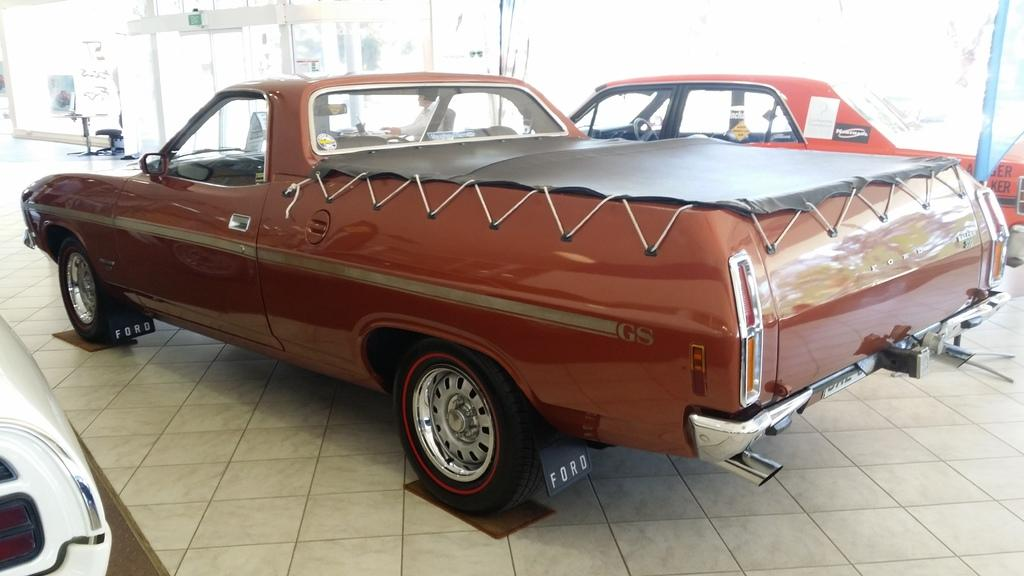What is the main subject in the center of the image? There are vehicles in the center of the image. What can be seen in the background of the image? In the background of the image, there are tables, chairs, banners, sign boards, and a person sitting. Can you describe the objects in the background of the image? There are other objects in the background of the image, including tables, chairs, banners, sign boards, and a person sitting. What type of kettle is visible in the image? There is no kettle present in the image. Can you describe the bulb used to light up the fan in the image? There is no fan or bulb present in the image. 